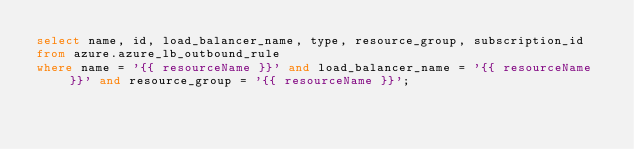<code> <loc_0><loc_0><loc_500><loc_500><_SQL_>select name, id, load_balancer_name, type, resource_group, subscription_id
from azure.azure_lb_outbound_rule
where name = '{{ resourceName }}' and load_balancer_name = '{{ resourceName }}' and resource_group = '{{ resourceName }}';
</code> 